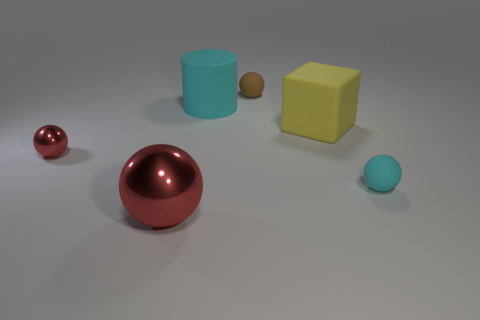Add 3 rubber cylinders. How many objects exist? 9 Subtract all cylinders. How many objects are left? 5 Subtract all big metallic cylinders. Subtract all cyan matte cylinders. How many objects are left? 5 Add 2 large cyan rubber things. How many large cyan rubber things are left? 3 Add 3 purple objects. How many purple objects exist? 3 Subtract 0 gray cylinders. How many objects are left? 6 